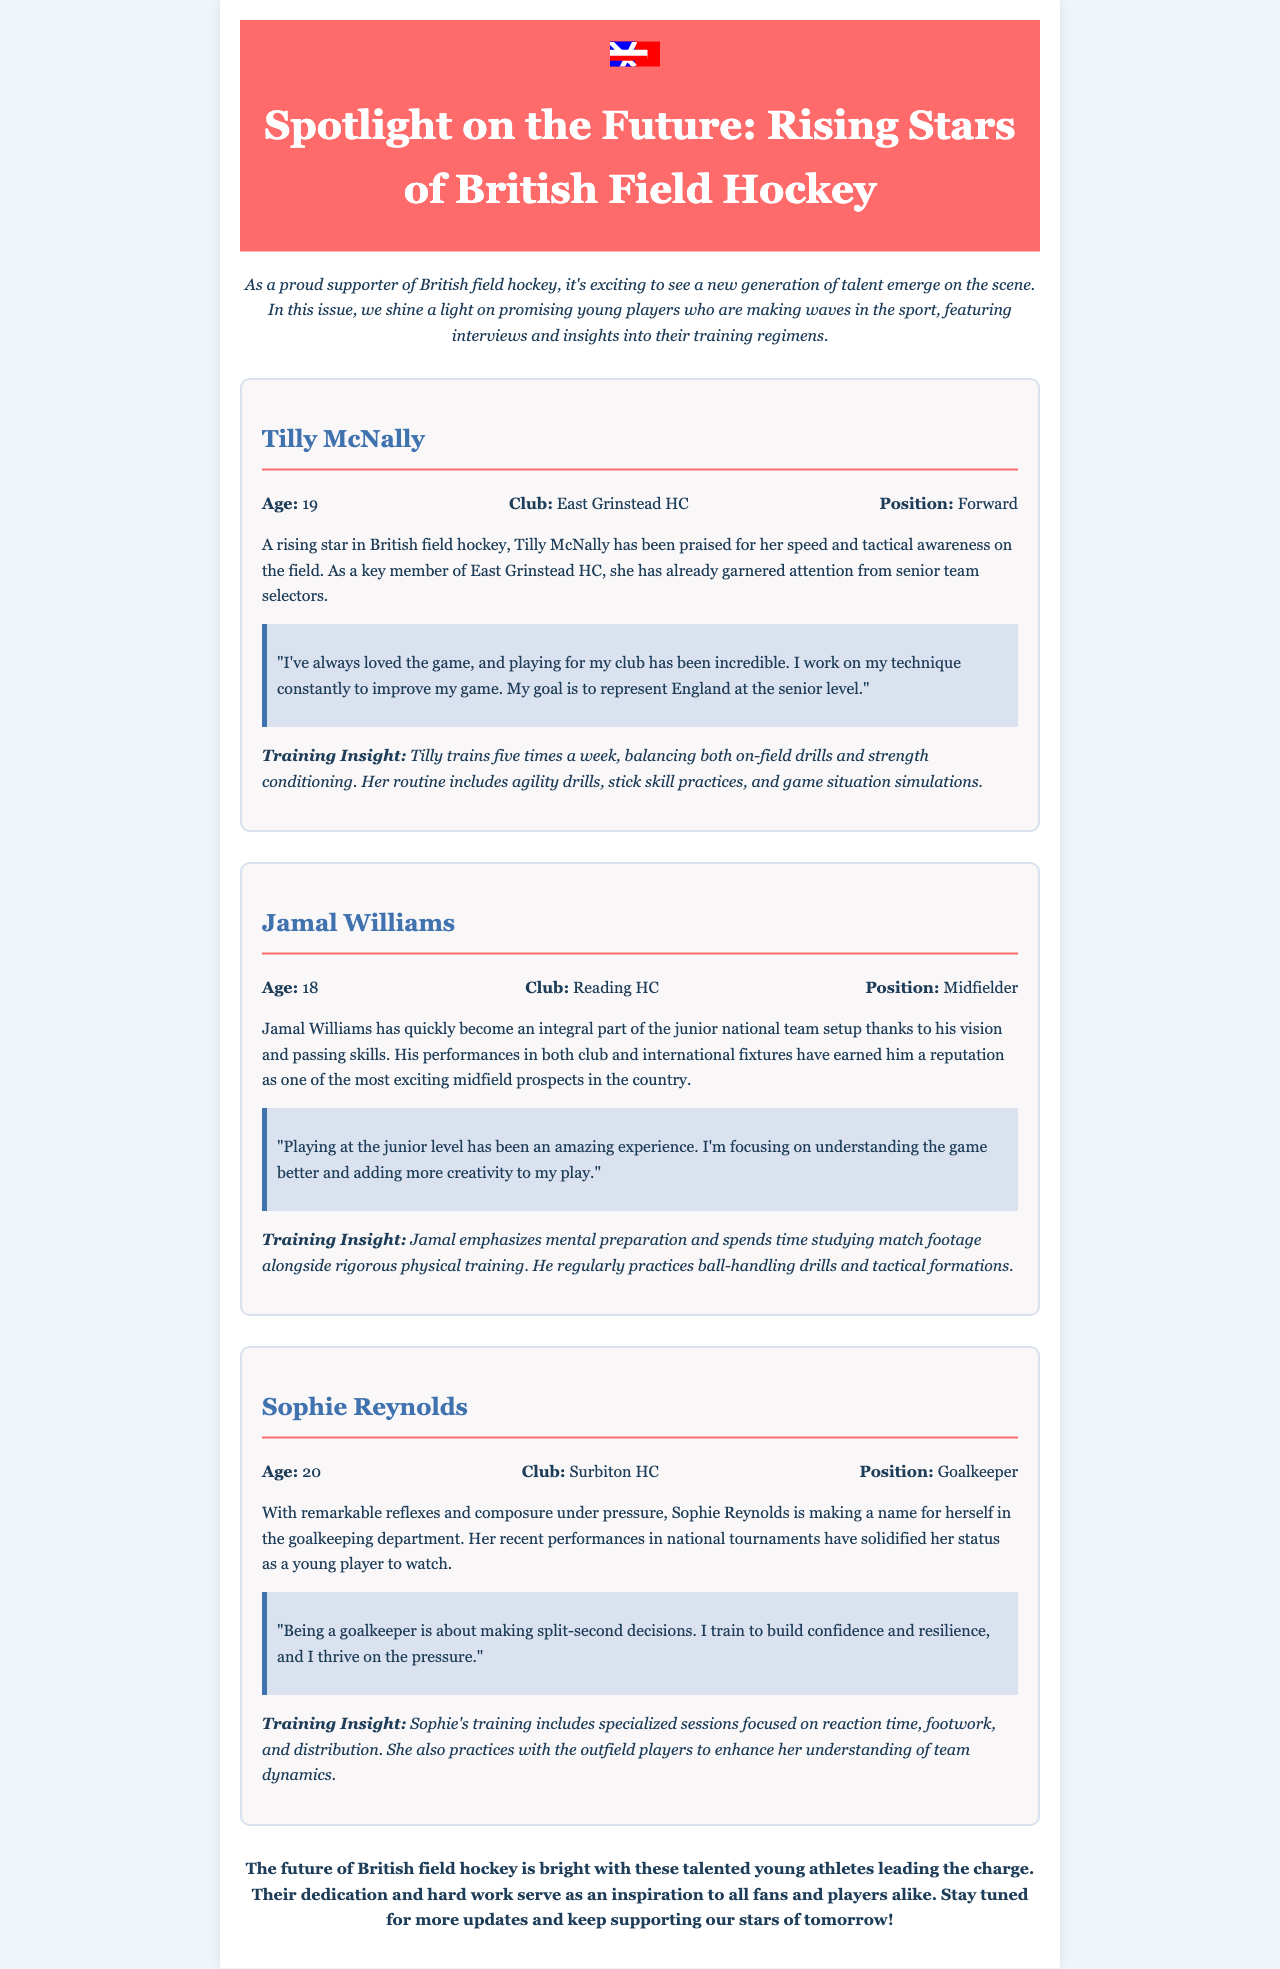what is the title of the newsletter? The title is prominently displayed at the top of the document, stating "Spotlight on the Future: Rising Stars of British Field Hockey."
Answer: Spotlight on the Future: Rising Stars of British Field Hockey how old is Tilly McNally? Tilly McNally's age is mentioned in her player card section.
Answer: 19 which club does Jamal Williams play for? The club for Jamal Williams is specified in his player card.
Answer: Reading HC what is Sophie's position on the field? Sophie's position is clearly indicated in her player card, labeled as "Position."
Answer: Goalkeeper how many times a week does Tilly McNally train? Tilly's training frequency is indicated in her training insight.
Answer: Five times which skill does Sophie focus on during her training? The document specifically mentions focus areas in Sophie's training.
Answer: Reaction time what aspect of his game is Jamal working on? Jamal's focus for improving his gameplay is found in his player quote.
Answer: Understanding the game better what does the newsletter encourage fans to do? The conclusion of the newsletter provides a call to action for fans.
Answer: Keep supporting our stars of tomorrow! 